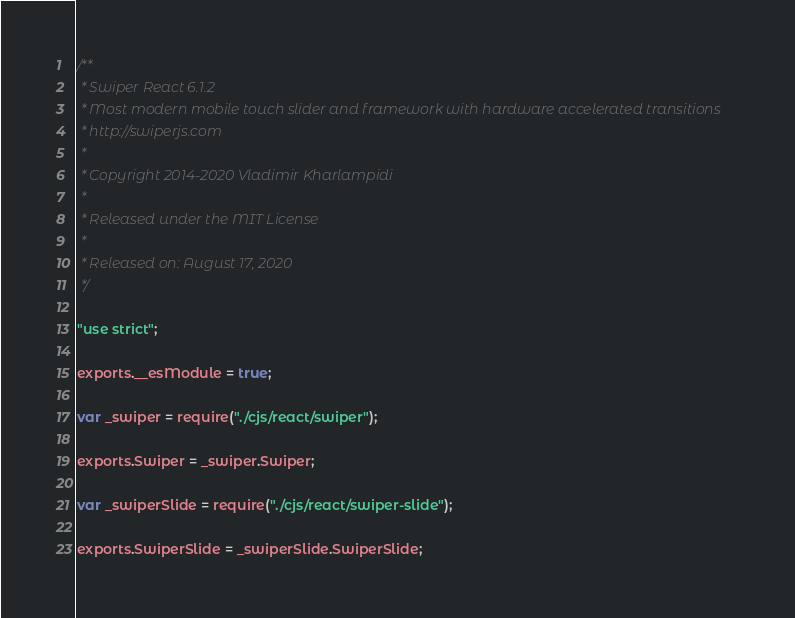Convert code to text. <code><loc_0><loc_0><loc_500><loc_500><_JavaScript_>/**
 * Swiper React 6.1.2
 * Most modern mobile touch slider and framework with hardware accelerated transitions
 * http://swiperjs.com
 *
 * Copyright 2014-2020 Vladimir Kharlampidi
 *
 * Released under the MIT License
 *
 * Released on: August 17, 2020
 */

"use strict";

exports.__esModule = true;

var _swiper = require("./cjs/react/swiper");

exports.Swiper = _swiper.Swiper;

var _swiperSlide = require("./cjs/react/swiper-slide");

exports.SwiperSlide = _swiperSlide.SwiperSlide;
</code> 